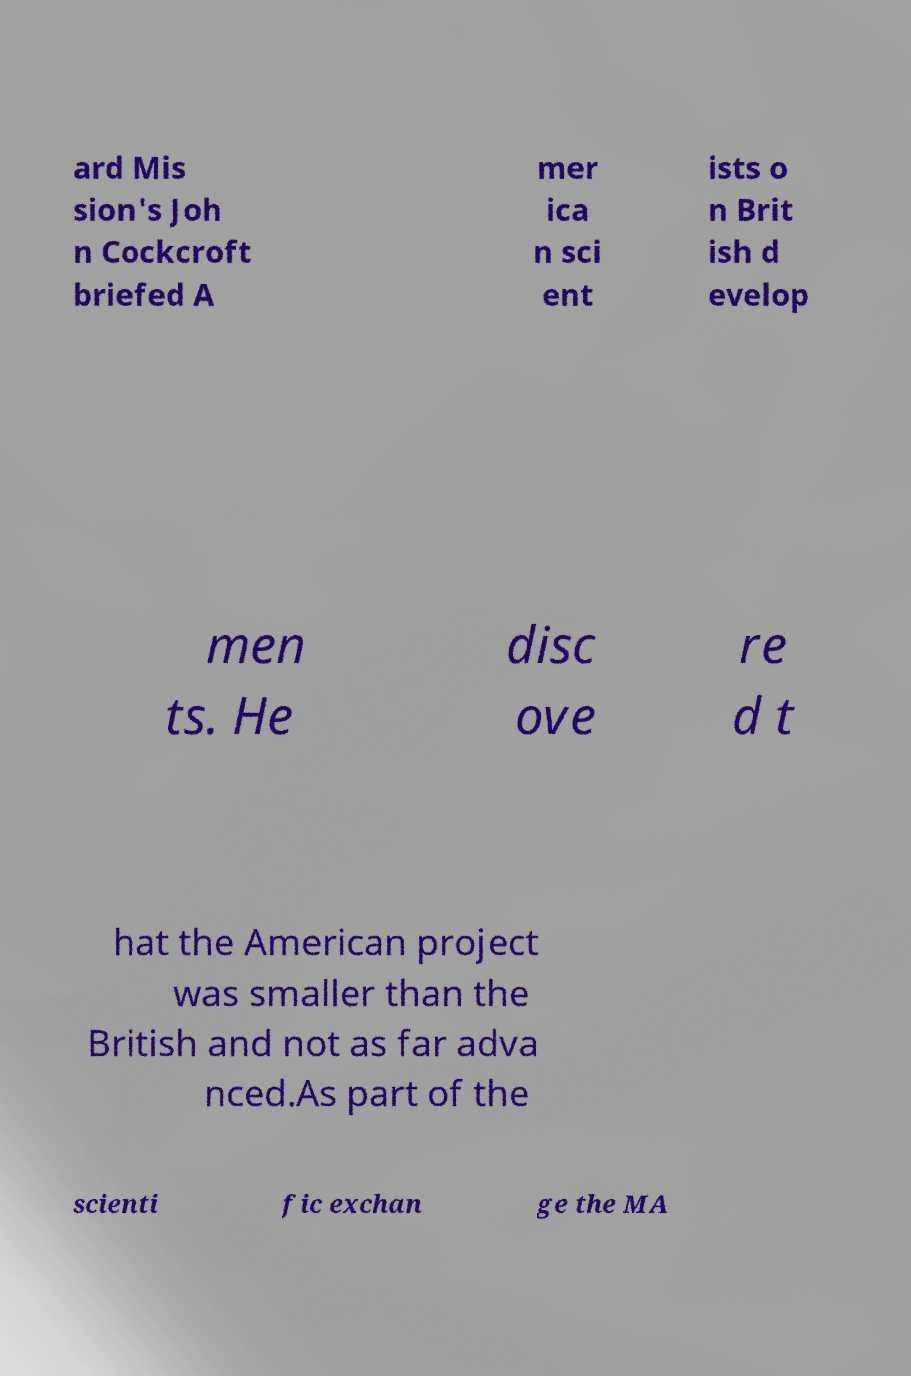Could you assist in decoding the text presented in this image and type it out clearly? ard Mis sion's Joh n Cockcroft briefed A mer ica n sci ent ists o n Brit ish d evelop men ts. He disc ove re d t hat the American project was smaller than the British and not as far adva nced.As part of the scienti fic exchan ge the MA 